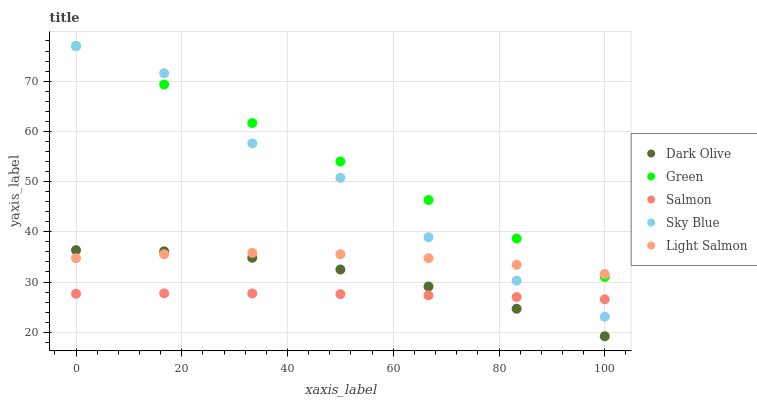Does Salmon have the minimum area under the curve?
Answer yes or no. Yes. Does Green have the maximum area under the curve?
Answer yes or no. Yes. Does Light Salmon have the minimum area under the curve?
Answer yes or no. No. Does Light Salmon have the maximum area under the curve?
Answer yes or no. No. Is Green the smoothest?
Answer yes or no. Yes. Is Sky Blue the roughest?
Answer yes or no. Yes. Is Light Salmon the smoothest?
Answer yes or no. No. Is Light Salmon the roughest?
Answer yes or no. No. Does Dark Olive have the lowest value?
Answer yes or no. Yes. Does Light Salmon have the lowest value?
Answer yes or no. No. Does Green have the highest value?
Answer yes or no. Yes. Does Light Salmon have the highest value?
Answer yes or no. No. Is Dark Olive less than Green?
Answer yes or no. Yes. Is Sky Blue greater than Dark Olive?
Answer yes or no. Yes. Does Light Salmon intersect Dark Olive?
Answer yes or no. Yes. Is Light Salmon less than Dark Olive?
Answer yes or no. No. Is Light Salmon greater than Dark Olive?
Answer yes or no. No. Does Dark Olive intersect Green?
Answer yes or no. No. 